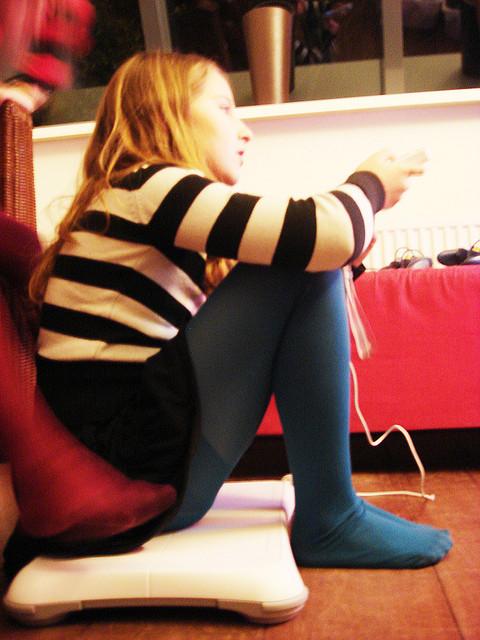How many colors are on her shirt?
Be succinct. 2. What is the lady sitting on?
Give a very brief answer. Pad. What game is she playing?
Be succinct. Wii. 